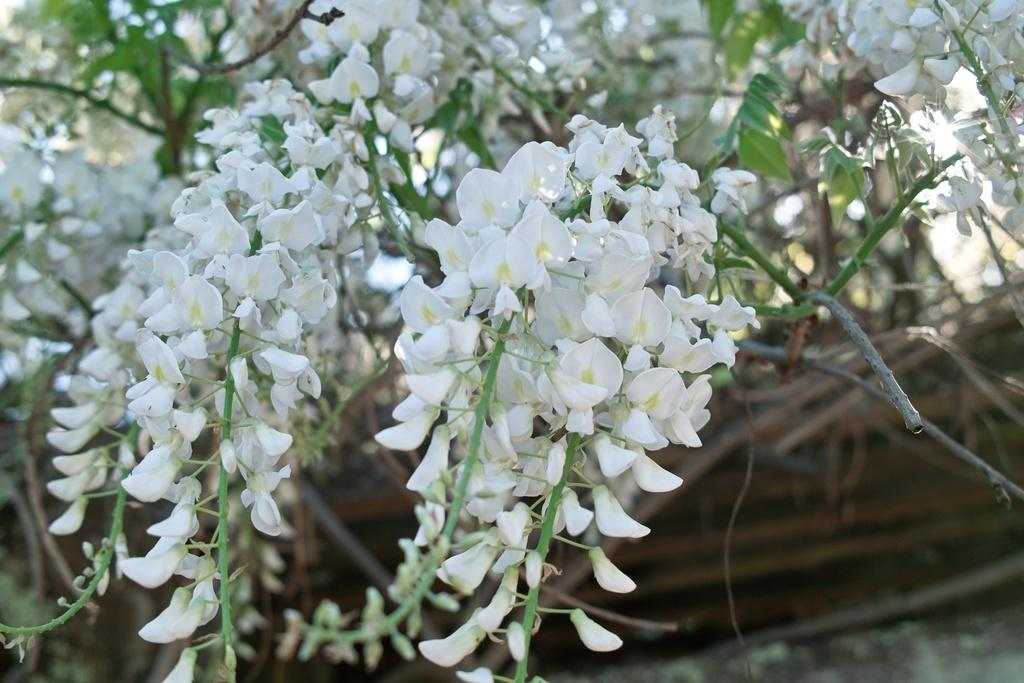What type of vegetation can be seen in the image? There are trees in the image. What other natural elements are present in the image? There are flowers in the image. How many servants are attending to the flowers in the image? There are no servants present in the image; it only features trees and flowers. What type of quilt is draped over the trees in the image? There is no quilt present in the image; it only features trees and flowers. 